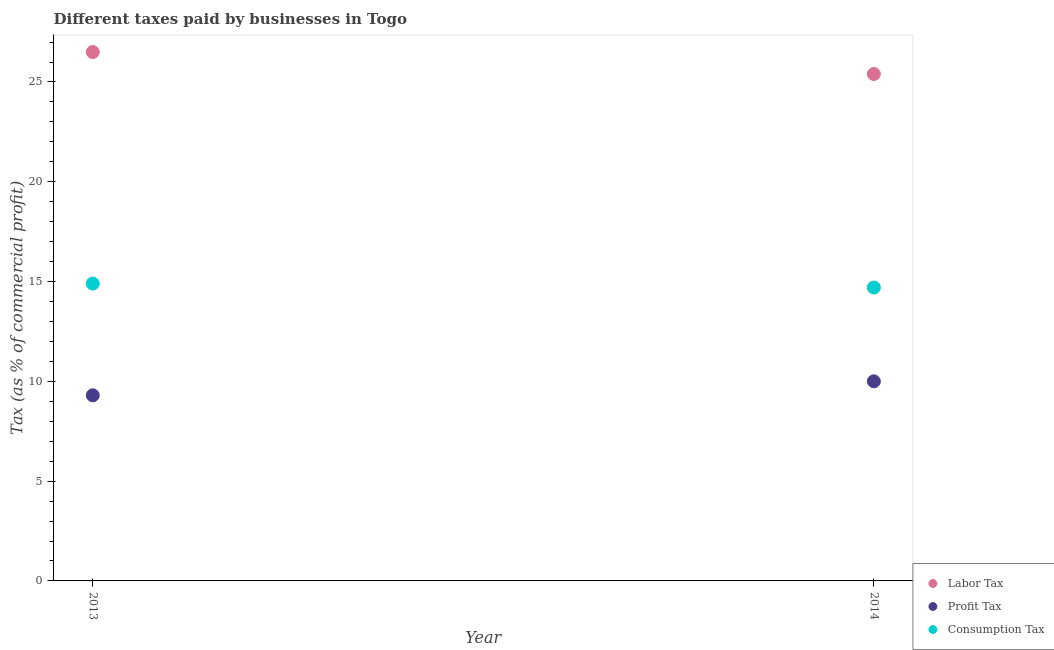How many different coloured dotlines are there?
Your response must be concise. 3. What is the percentage of profit tax in 2013?
Your answer should be very brief. 9.3. Across all years, what is the minimum percentage of consumption tax?
Provide a short and direct response. 14.7. What is the total percentage of profit tax in the graph?
Give a very brief answer. 19.3. What is the difference between the percentage of labor tax in 2013 and that in 2014?
Offer a terse response. 1.1. What is the difference between the percentage of labor tax in 2014 and the percentage of profit tax in 2013?
Your response must be concise. 16.1. What is the average percentage of profit tax per year?
Make the answer very short. 9.65. In the year 2014, what is the difference between the percentage of consumption tax and percentage of labor tax?
Your answer should be compact. -10.7. In how many years, is the percentage of consumption tax greater than 25 %?
Make the answer very short. 0. What is the ratio of the percentage of profit tax in 2013 to that in 2014?
Provide a succinct answer. 0.93. Is the percentage of labor tax in 2013 less than that in 2014?
Give a very brief answer. No. In how many years, is the percentage of labor tax greater than the average percentage of labor tax taken over all years?
Offer a terse response. 1. Is the percentage of labor tax strictly greater than the percentage of consumption tax over the years?
Ensure brevity in your answer.  Yes. How many dotlines are there?
Make the answer very short. 3. What is the difference between two consecutive major ticks on the Y-axis?
Ensure brevity in your answer.  5. Are the values on the major ticks of Y-axis written in scientific E-notation?
Offer a very short reply. No. Does the graph contain grids?
Your answer should be very brief. No. Where does the legend appear in the graph?
Make the answer very short. Bottom right. What is the title of the graph?
Give a very brief answer. Different taxes paid by businesses in Togo. What is the label or title of the Y-axis?
Provide a short and direct response. Tax (as % of commercial profit). What is the Tax (as % of commercial profit) in Labor Tax in 2013?
Provide a short and direct response. 26.5. What is the Tax (as % of commercial profit) of Profit Tax in 2013?
Ensure brevity in your answer.  9.3. What is the Tax (as % of commercial profit) of Labor Tax in 2014?
Keep it short and to the point. 25.4. What is the Tax (as % of commercial profit) of Consumption Tax in 2014?
Give a very brief answer. 14.7. Across all years, what is the maximum Tax (as % of commercial profit) of Profit Tax?
Ensure brevity in your answer.  10. Across all years, what is the minimum Tax (as % of commercial profit) of Labor Tax?
Provide a short and direct response. 25.4. Across all years, what is the minimum Tax (as % of commercial profit) in Profit Tax?
Ensure brevity in your answer.  9.3. Across all years, what is the minimum Tax (as % of commercial profit) of Consumption Tax?
Give a very brief answer. 14.7. What is the total Tax (as % of commercial profit) in Labor Tax in the graph?
Your answer should be compact. 51.9. What is the total Tax (as % of commercial profit) in Profit Tax in the graph?
Keep it short and to the point. 19.3. What is the total Tax (as % of commercial profit) in Consumption Tax in the graph?
Keep it short and to the point. 29.6. What is the difference between the Tax (as % of commercial profit) in Labor Tax in 2013 and that in 2014?
Keep it short and to the point. 1.1. What is the difference between the Tax (as % of commercial profit) in Profit Tax in 2013 and that in 2014?
Provide a succinct answer. -0.7. What is the difference between the Tax (as % of commercial profit) of Labor Tax in 2013 and the Tax (as % of commercial profit) of Profit Tax in 2014?
Provide a succinct answer. 16.5. What is the difference between the Tax (as % of commercial profit) in Labor Tax in 2013 and the Tax (as % of commercial profit) in Consumption Tax in 2014?
Offer a terse response. 11.8. What is the difference between the Tax (as % of commercial profit) in Profit Tax in 2013 and the Tax (as % of commercial profit) in Consumption Tax in 2014?
Your response must be concise. -5.4. What is the average Tax (as % of commercial profit) of Labor Tax per year?
Your answer should be very brief. 25.95. What is the average Tax (as % of commercial profit) of Profit Tax per year?
Keep it short and to the point. 9.65. What is the average Tax (as % of commercial profit) of Consumption Tax per year?
Offer a very short reply. 14.8. In the year 2014, what is the difference between the Tax (as % of commercial profit) of Labor Tax and Tax (as % of commercial profit) of Consumption Tax?
Provide a short and direct response. 10.7. In the year 2014, what is the difference between the Tax (as % of commercial profit) in Profit Tax and Tax (as % of commercial profit) in Consumption Tax?
Offer a terse response. -4.7. What is the ratio of the Tax (as % of commercial profit) in Labor Tax in 2013 to that in 2014?
Provide a succinct answer. 1.04. What is the ratio of the Tax (as % of commercial profit) in Profit Tax in 2013 to that in 2014?
Your answer should be very brief. 0.93. What is the ratio of the Tax (as % of commercial profit) of Consumption Tax in 2013 to that in 2014?
Your answer should be very brief. 1.01. What is the difference between the highest and the second highest Tax (as % of commercial profit) of Labor Tax?
Your answer should be very brief. 1.1. What is the difference between the highest and the second highest Tax (as % of commercial profit) in Consumption Tax?
Provide a short and direct response. 0.2. 